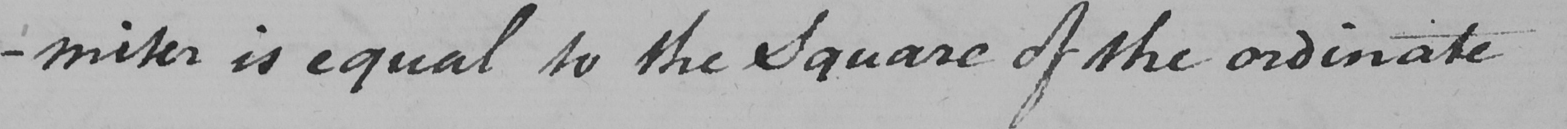What text is written in this handwritten line? -miter is equal to the Square of the ordinate 